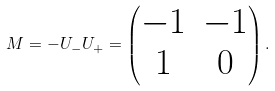<formula> <loc_0><loc_0><loc_500><loc_500>M = - U _ { - } U _ { + } = \begin{pmatrix} - 1 & - 1 \\ 1 & 0 \end{pmatrix} .</formula> 